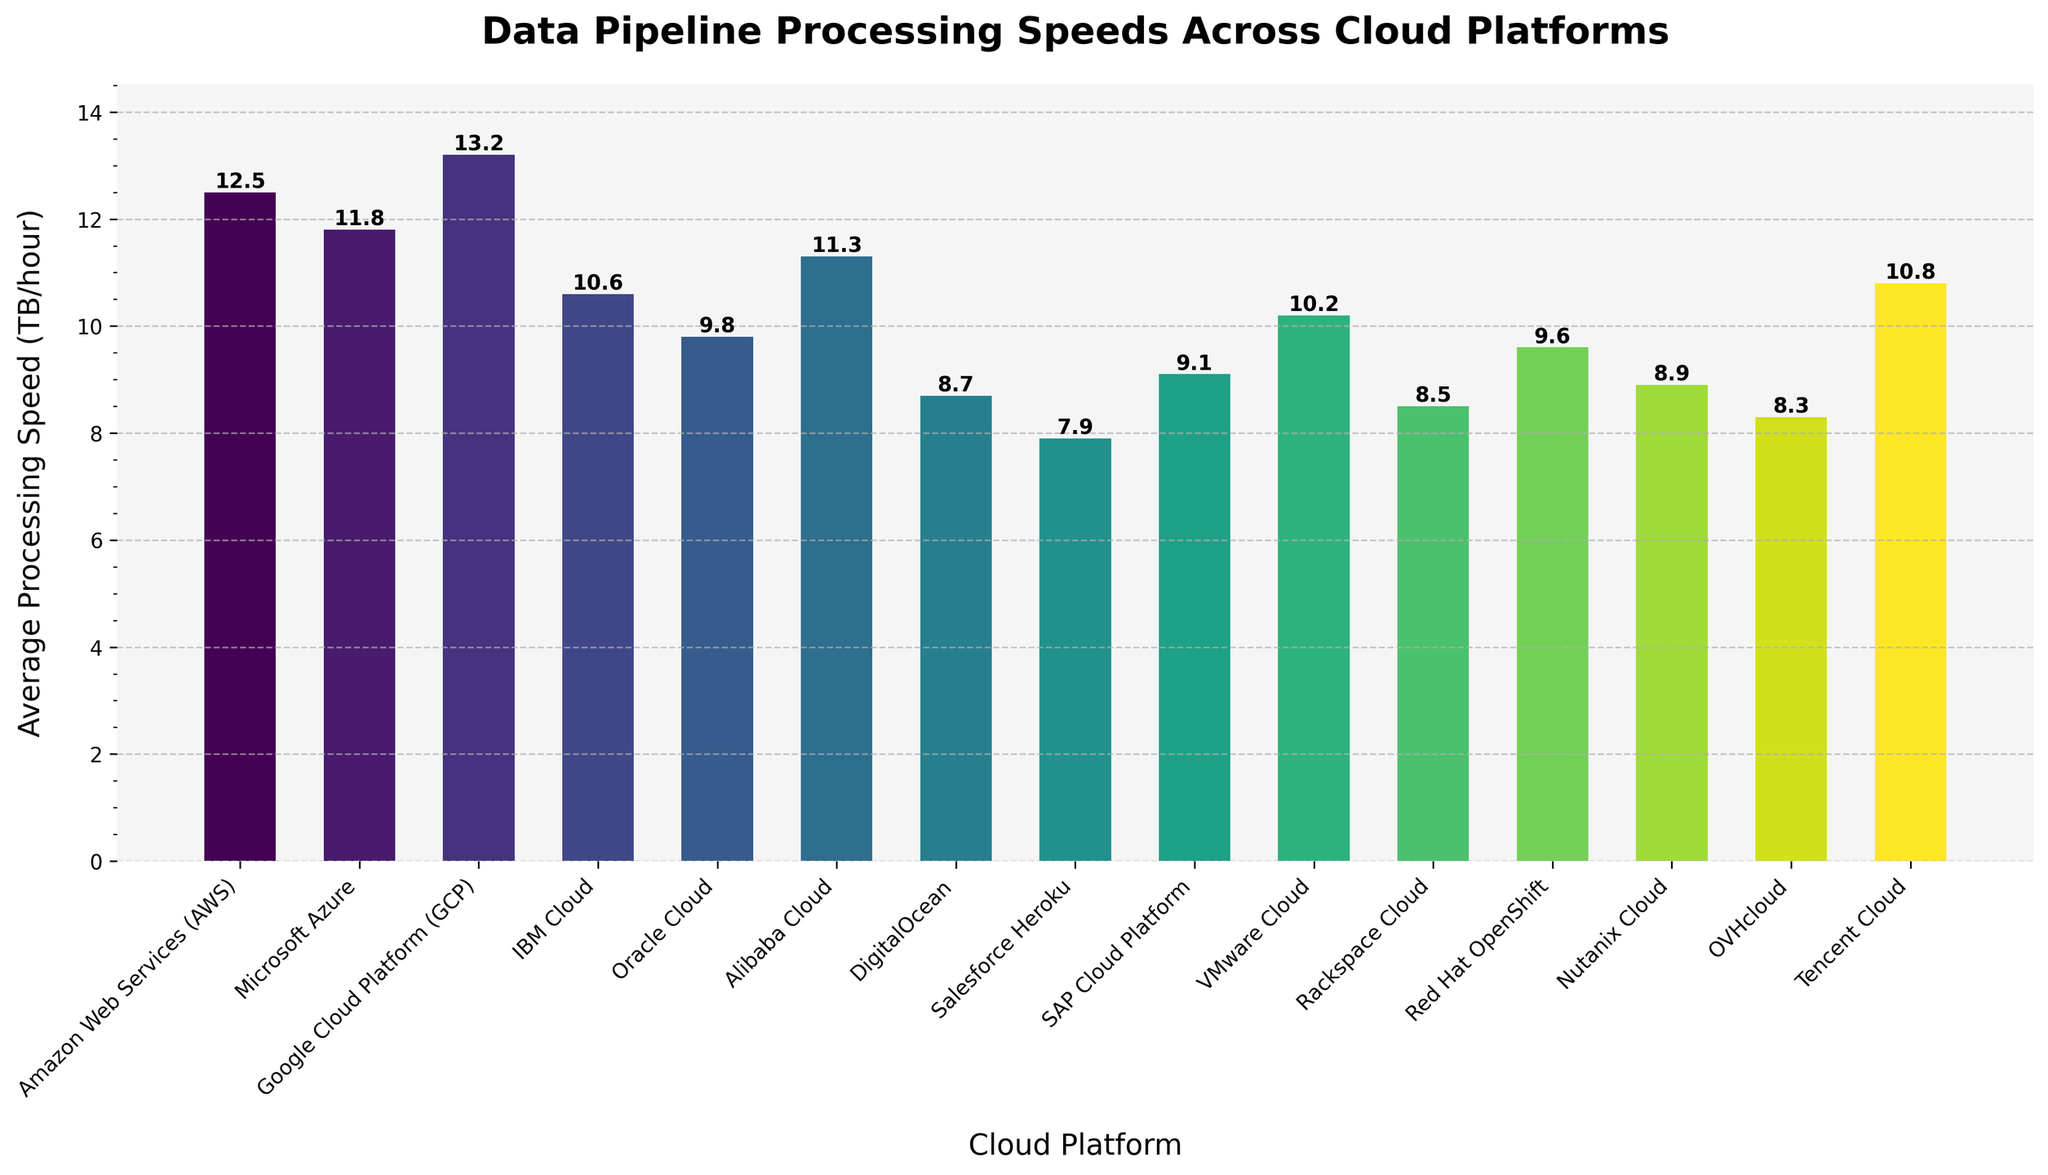Which cloud platform has the highest average processing speed? Identify the bar with the greatest height, which represents Google Cloud Platform (GCP) with an average processing speed of 13.2 TB/hour.
Answer: Google Cloud Platform (GCP) Which cloud platform has the lowest average processing speed? Identify the bar with the shortest height, which represents Salesforce Heroku with an average processing speed of 7.9 TB/hour.
Answer: Salesforce Heroku How much faster is Amazon Web Services (AWS) compared to Oracle Cloud? Subtract the average processing speed of Oracle Cloud from AWS (12.5 - 9.8), resulting in a difference of 2.7 TB/hour.
Answer: 2.7 Which cloud platforms have average processing speeds greater than 10 TB/hour? Identify the platforms where the bar heights exceed the 10 TB/hour mark: AWS, Microsoft Azure, GCP, IBM Cloud, Alibaba Cloud, Tencent Cloud, and VMware Cloud.
Answer: AWS, Microsoft Azure, GCP, IBM Cloud, Alibaba Cloud, Tencent Cloud, VMware Cloud What is the average processing speed of all the platforms combined? Add the average processing speeds of all platforms (12.5 + 11.8 + 13.2 + 10.6 + 9.8 + 11.3 + 8.7 + 7.9 + 9.1 + 10.2 + 8.5 + 9.6 + 8.9 + 8.3 + 10.8) and divide by the number of platforms (15), resulting in a combined average. (150.2 / 15)
Answer: 10.0 Which platform has a speed closest to the average processing speed across all platforms? Calculate the average speed (10.0 TB/hour) and identify the bar whose height most closely matches this value, which is IBM Cloud with 10.6 TB/hour.
Answer: IBM Cloud Order the cloud platforms from fastest to slowest average processing speed. List the platforms by their bar heights in descending order: GCP, AWS, Microsoft Azure, Alibaba Cloud, Tencent Cloud, IBM Cloud, VMware Cloud, Red Hat OpenShift, Oracle Cloud, SAP Cloud Platform, Nutanix Cloud, DigitalOcean, OVHcloud, Rackspace Cloud, Salesforce Heroku.
Answer: GCP, AWS, Microsoft Azure, Alibaba Cloud, Tencent Cloud, IBM Cloud, VMware Cloud, Red Hat OpenShift, Oracle Cloud, SAP Cloud Platform, Nutanix Cloud, DigitalOcean, OVHcloud, Rackspace Cloud, Salesforce Heroku What is the difference in average processing speed between Alibaba Cloud and DigitalOcean? Subtract the average processing speed of DigitalOcean from Alibaba Cloud (11.3 - 8.7), resulting in a difference of 2.6 TB/hour.
Answer: 2.6 How many platforms have a processing speed below 9 TB/hour? Count the bars which have heights lower than 9 TB/hour: Salesforce Heroku, Rackspace Cloud, OVHcloud, Nutanix Cloud, and DigitalOcean (5 platforms).
Answer: 5 What is the combined processing speed of Microsoft's Azure and IBM Cloud platforms? Add the average processing speeds of Azure and IBM Cloud (11.8 + 10.6), resulting in a combined speed of 22.4 TB/hour.
Answer: 22.4 